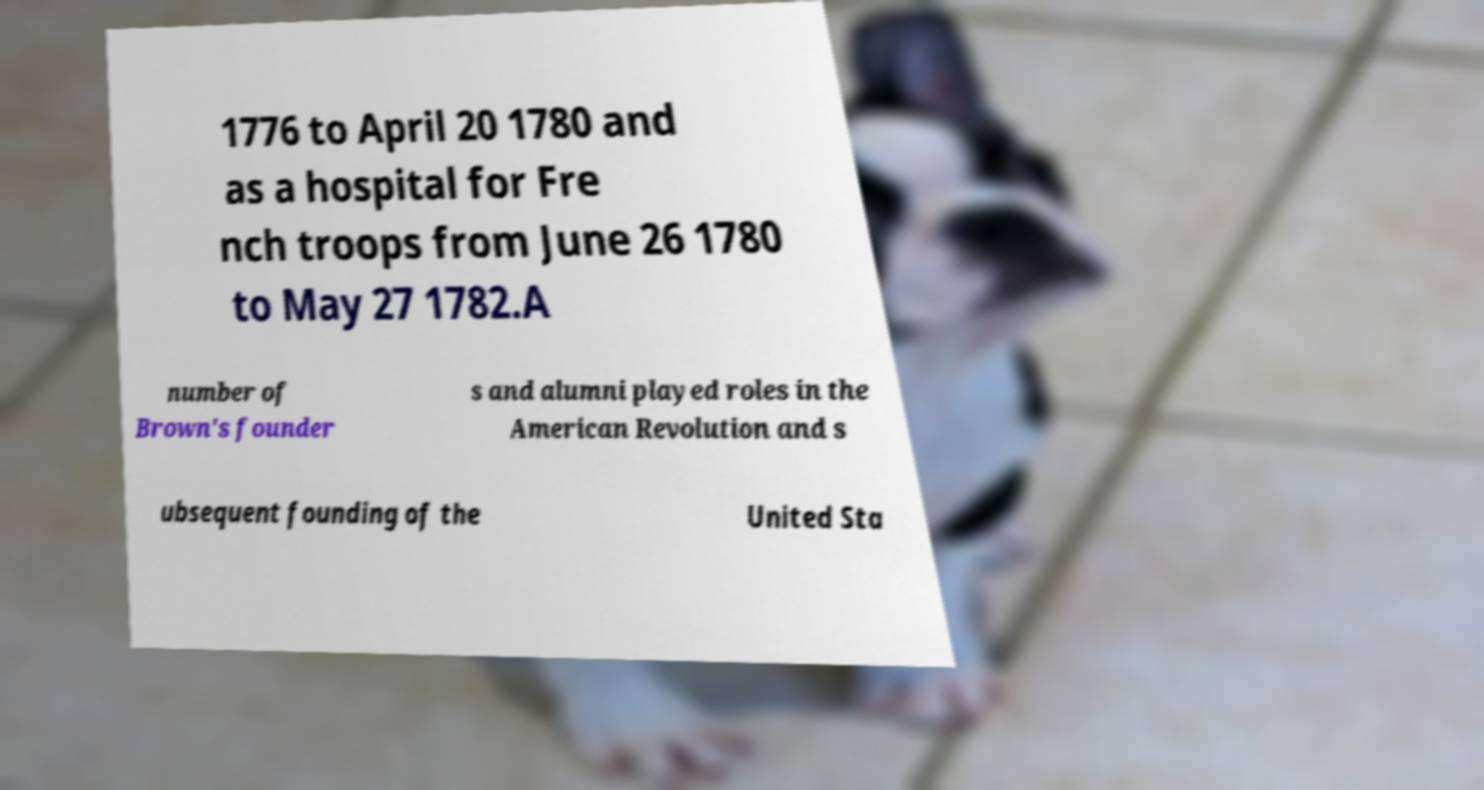What messages or text are displayed in this image? I need them in a readable, typed format. 1776 to April 20 1780 and as a hospital for Fre nch troops from June 26 1780 to May 27 1782.A number of Brown's founder s and alumni played roles in the American Revolution and s ubsequent founding of the United Sta 